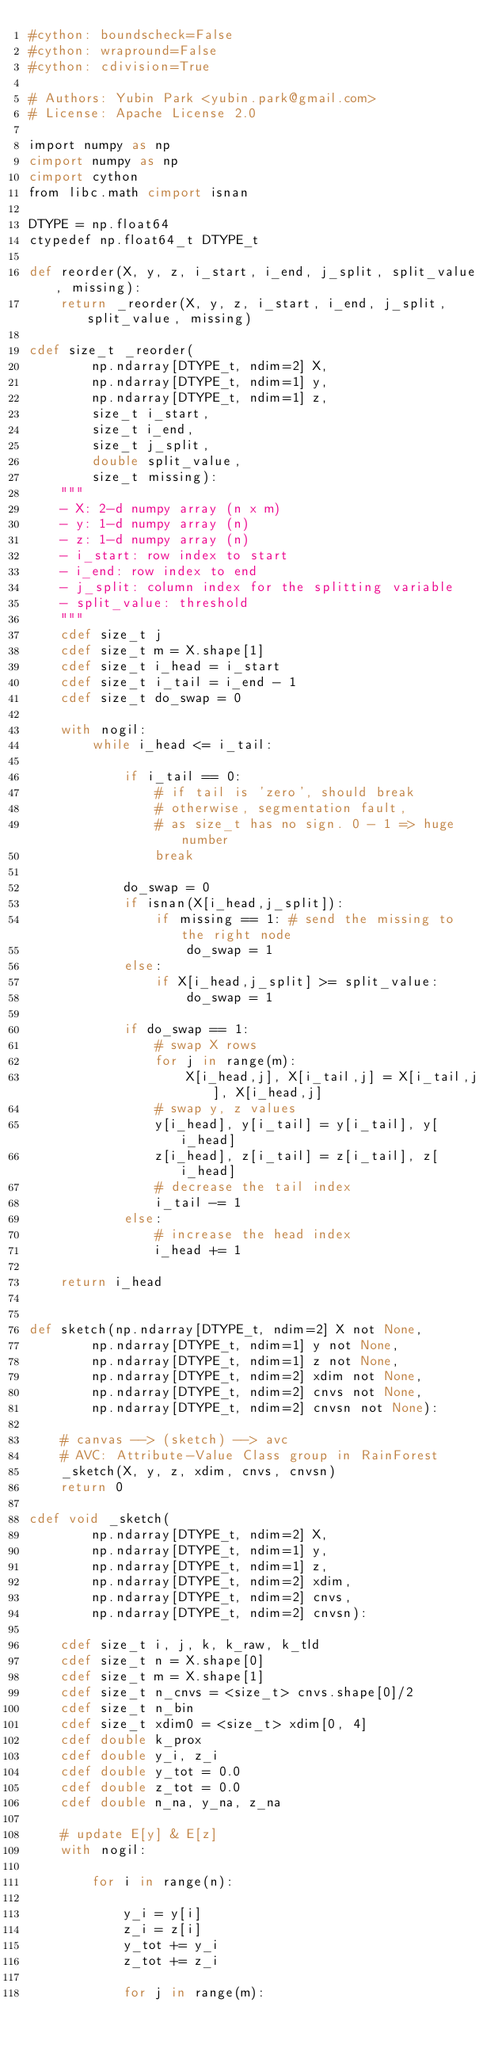<code> <loc_0><loc_0><loc_500><loc_500><_Cython_>#cython: boundscheck=False
#cython: wrapround=False
#cython: cdivision=True

# Authors: Yubin Park <yubin.park@gmail.com>
# License: Apache License 2.0

import numpy as np
cimport numpy as np
cimport cython
from libc.math cimport isnan

DTYPE = np.float64
ctypedef np.float64_t DTYPE_t

def reorder(X, y, z, i_start, i_end, j_split, split_value, missing):
    return _reorder(X, y, z, i_start, i_end, j_split, split_value, missing)
 
cdef size_t _reorder(
        np.ndarray[DTYPE_t, ndim=2] X, 
        np.ndarray[DTYPE_t, ndim=1] y, 
        np.ndarray[DTYPE_t, ndim=1] z, 
        size_t i_start, 
        size_t i_end, 
        size_t j_split, 
        double split_value, 
        size_t missing):
    """
    - X: 2-d numpy array (n x m)
    - y: 1-d numpy array (n)
    - z: 1-d numpy array (n)
    - i_start: row index to start
    - i_end: row index to end
    - j_split: column index for the splitting variable
    - split_value: threshold
    """
    cdef size_t j
    cdef size_t m = X.shape[1]
    cdef size_t i_head = i_start
    cdef size_t i_tail = i_end - 1
    cdef size_t do_swap = 0

    with nogil:
        while i_head <= i_tail:

            if i_tail == 0: 
                # if tail is 'zero', should break
                # otherwise, segmentation fault, 
                # as size_t has no sign. 0 - 1 => huge number
                break
            
            do_swap = 0 
            if isnan(X[i_head,j_split]):
                if missing == 1: # send the missing to the right node
                    do_swap = 1
            else:
                if X[i_head,j_split] >= split_value:
                    do_swap = 1

            if do_swap == 1:
                # swap X rows
                for j in range(m):
                    X[i_head,j], X[i_tail,j] = X[i_tail,j], X[i_head,j]
                # swap y, z values
                y[i_head], y[i_tail] = y[i_tail], y[i_head]
                z[i_head], z[i_tail] = z[i_tail], z[i_head]
                # decrease the tail index
                i_tail -= 1
            else:
                # increase the head index
                i_head += 1

    return i_head


def sketch(np.ndarray[DTYPE_t, ndim=2] X not None, 
        np.ndarray[DTYPE_t, ndim=1] y not None, 
        np.ndarray[DTYPE_t, ndim=1] z not None, 
        np.ndarray[DTYPE_t, ndim=2] xdim not None, 
        np.ndarray[DTYPE_t, ndim=2] cnvs not None, 
        np.ndarray[DTYPE_t, ndim=2] cnvsn not None):

    # canvas --> (sketch) --> avc 
    # AVC: Attribute-Value Class group in RainForest
    _sketch(X, y, z, xdim, cnvs, cnvsn)
    return 0

cdef void _sketch(
        np.ndarray[DTYPE_t, ndim=2] X, 
        np.ndarray[DTYPE_t, ndim=1] y, 
        np.ndarray[DTYPE_t, ndim=1] z, 
        np.ndarray[DTYPE_t, ndim=2] xdim, 
        np.ndarray[DTYPE_t, ndim=2] cnvs, 
        np.ndarray[DTYPE_t, ndim=2] cnvsn):

    cdef size_t i, j, k, k_raw, k_tld
    cdef size_t n = X.shape[0]
    cdef size_t m = X.shape[1]
    cdef size_t n_cnvs = <size_t> cnvs.shape[0]/2
    cdef size_t n_bin
    cdef size_t xdim0 = <size_t> xdim[0, 4]
    cdef double k_prox
    cdef double y_i, z_i
    cdef double y_tot = 0.0
    cdef double z_tot = 0.0
    cdef double n_na, y_na, z_na

    # update E[y] & E[z]
    with nogil:

        for i in range(n):

            y_i = y[i]
            z_i = z[i]
            y_tot += y_i
            z_tot += z_i

            for j in range(m):
</code> 